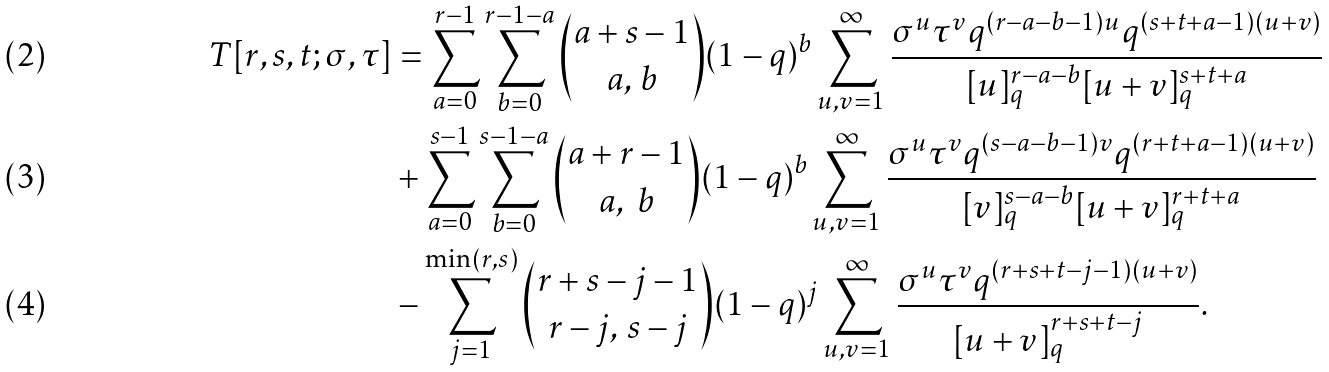Convert formula to latex. <formula><loc_0><loc_0><loc_500><loc_500>T [ r , s , t ; \sigma , \tau ] & = \sum _ { a = 0 } ^ { r - 1 } \sum _ { b = 0 } ^ { r - 1 - a } \binom { a + s - 1 } { a , \, b } ( 1 - q ) ^ { b } \sum _ { u , v = 1 } ^ { \infty } \frac { \sigma ^ { u } \tau ^ { v } q ^ { ( r - a - b - 1 ) u } q ^ { ( s + t + a - 1 ) ( u + v ) } } { [ u ] _ { q } ^ { r - a - b } [ u + v ] _ { q } ^ { s + t + a } } \\ & + \sum _ { a = 0 } ^ { s - 1 } \sum _ { b = 0 } ^ { s - 1 - a } \binom { a + r - 1 } { a , \ b } ( 1 - q ) ^ { b } \sum _ { u , v = 1 } ^ { \infty } \frac { \sigma ^ { u } \tau ^ { v } q ^ { ( s - a - b - 1 ) v } q ^ { ( r + t + a - 1 ) ( u + v ) } } { [ v ] _ { q } ^ { s - a - b } [ u + v ] _ { q } ^ { r + t + a } } \\ & - \sum _ { j = 1 } ^ { \min ( r , s ) } \binom { r + s - j - 1 } { r - j , \, s - j } ( 1 - q ) ^ { j } \sum _ { u , v = 1 } ^ { \infty } \frac { \sigma ^ { u } \tau ^ { v } q ^ { ( r + s + t - j - 1 ) ( u + v ) } } { [ u + v ] _ { q } ^ { r + s + t - j } } .</formula> 